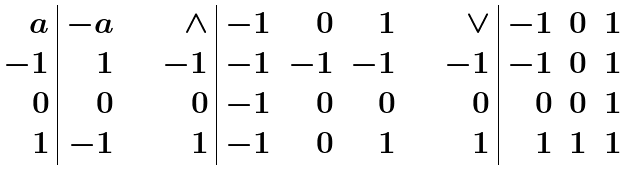Convert formula to latex. <formula><loc_0><loc_0><loc_500><loc_500>\begin{array} { r | r } a & - a \\ - 1 & 1 \\ 0 & 0 \\ 1 & - 1 \end{array} \quad \begin{array} { r | r r r } \wedge & - 1 & 0 & 1 \\ - 1 & - 1 & - 1 & - 1 \\ 0 & - 1 & 0 & 0 \\ 1 & - 1 & 0 & 1 \end{array} \quad \begin{array} { r | r r r } \vee & - 1 & 0 & 1 \\ - 1 & - 1 & 0 & 1 \\ 0 & 0 & 0 & 1 \\ 1 & 1 & 1 & 1 \end{array}</formula> 